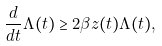<formula> <loc_0><loc_0><loc_500><loc_500>\frac { d } { d t } \Lambda ( t ) \geq 2 \beta z ( t ) \Lambda ( t ) ,</formula> 